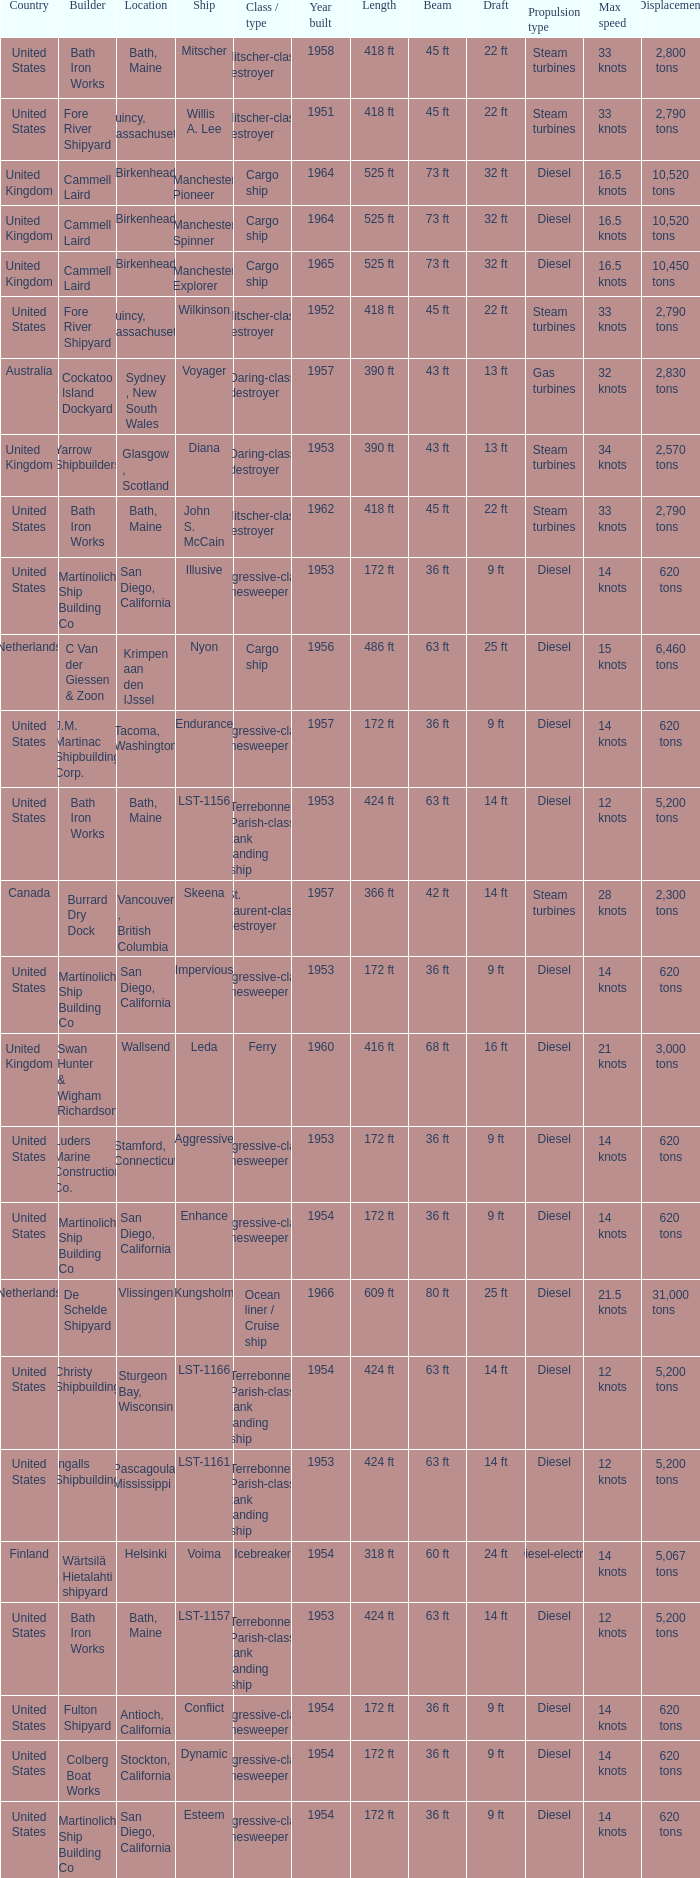Would you be able to parse every entry in this table? {'header': ['Country', 'Builder', 'Location', 'Ship', 'Class / type', 'Year built', 'Length', 'Beam', 'Draft', 'Propulsion type', 'Max speed', 'Displacement'], 'rows': [['United States', 'Bath Iron Works', 'Bath, Maine', 'Mitscher', 'Mitscher-class destroyer', '1958', '418 ft', '45 ft', '22 ft', 'Steam turbines', '33 knots', '2,800 tons'], ['United States', 'Fore River Shipyard', 'Quincy, Massachusetts', 'Willis A. Lee', 'Mitscher-class destroyer', '1951', '418 ft', '45 ft', '22 ft', 'Steam turbines', '33 knots', '2,790 tons'], ['United Kingdom', 'Cammell Laird', 'Birkenhead', 'Manchester Pioneer', 'Cargo ship', '1964', '525 ft', '73 ft', '32 ft', 'Diesel', '16.5 knots', '10,520 tons'], ['United Kingdom', 'Cammell Laird', 'Birkenhead', 'Manchester Spinner', 'Cargo ship', '1964', '525 ft', '73 ft', '32 ft', 'Diesel', '16.5 knots', '10,520 tons'], ['United Kingdom', 'Cammell Laird', 'Birkenhead', 'Manchester Explorer', 'Cargo ship', '1965', '525 ft', '73 ft', '32 ft', 'Diesel', '16.5 knots', '10,450 tons'], ['United States', 'Fore River Shipyard', 'Quincy, Massachusetts', 'Wilkinson', 'Mitscher-class destroyer', '1952', '418 ft', '45 ft', '22 ft', 'Steam turbines', '33 knots', '2,790 tons'], ['Australia', 'Cockatoo Island Dockyard', 'Sydney , New South Wales', 'Voyager', 'Daring-class destroyer', '1957', '390 ft', '43 ft', '13 ft', 'Gas turbines', '32 knots', '2,830 tons'], ['United Kingdom', 'Yarrow Shipbuilders', 'Glasgow , Scotland', 'Diana', 'Daring-class destroyer', '1953', '390 ft', '43 ft', '13 ft', 'Steam turbines', '34 knots', '2,570 tons'], ['United States', 'Bath Iron Works', 'Bath, Maine', 'John S. McCain', 'Mitscher-class destroyer', '1962', '418 ft', '45 ft', '22 ft', 'Steam turbines', '33 knots', '2,790 tons'], ['United States', 'Martinolich Ship Building Co', 'San Diego, California', 'Illusive', 'Aggressive-class minesweeper', '1953', '172 ft', '36 ft', '9 ft', 'Diesel', '14 knots', '620 tons'], ['Netherlands', 'C Van der Giessen & Zoon', 'Krimpen aan den IJssel', 'Nyon', 'Cargo ship', '1956', '486 ft', '63 ft', '25 ft', 'Diesel', '15 knots', '6,460 tons'], ['United States', 'J.M. Martinac Shipbuilding Corp.', 'Tacoma, Washington', 'Endurance', 'Aggressive-class minesweeper', '1957', '172 ft', '36 ft', '9 ft', 'Diesel', '14 knots', '620 tons'], ['United States', 'Bath Iron Works', 'Bath, Maine', 'LST-1156', 'Terrebonne Parish-class tank landing ship', '1953', '424 ft', '63 ft', '14 ft', 'Diesel', '12 knots', '5,200 tons'], ['Canada', 'Burrard Dry Dock', 'Vancouver , British Columbia', 'Skeena', 'St. Laurent-class destroyer', '1957', '366 ft', '42 ft', '14 ft', 'Steam turbines', '28 knots', '2,300 tons'], ['United States', 'Martinolich Ship Building Co', 'San Diego, California', 'Impervious', 'Aggressive-class minesweeper', '1953', '172 ft', '36 ft', '9 ft', 'Diesel', '14 knots', '620 tons'], ['United Kingdom', 'Swan Hunter & Wigham Richardson', 'Wallsend', 'Leda', 'Ferry', '1960', '416 ft', '68 ft', '16 ft', 'Diesel', '21 knots', '3,000 tons'], ['United States', 'Luders Marine Construction Co.', 'Stamford, Connecticut', 'Aggressive', 'Aggressive-class minesweeper', '1953', '172 ft', '36 ft', '9 ft', 'Diesel', '14 knots', '620 tons'], ['United States', 'Martinolich Ship Building Co', 'San Diego, California', 'Enhance', 'Aggressive-class minesweeper', '1954', '172 ft', '36 ft', '9 ft', 'Diesel', '14 knots', '620 tons'], ['Netherlands', 'De Schelde Shipyard', 'Vlissingen', 'Kungsholm', 'Ocean liner / Cruise ship', '1966', '609 ft', '80 ft', '25 ft', 'Diesel', '21.5 knots', '31,000 tons'], ['United States', 'Christy Shipbuilding', 'Sturgeon Bay, Wisconsin', 'LST-1166', 'Terrebonne Parish-class tank landing ship', '1954', '424 ft', '63 ft', '14 ft', 'Diesel', '12 knots', '5,200 tons'], ['United States', 'Ingalls Shipbuilding', 'Pascagoula, Mississippi', 'LST-1161', 'Terrebonne Parish-class tank landing ship', '1953', '424 ft', '63 ft', '14 ft', 'Diesel', '12 knots', '5,200 tons'], ['Finland', 'Wärtsilä Hietalahti shipyard', 'Helsinki', 'Voima', 'Icebreaker', '1954', '318 ft', '60 ft', '24 ft', 'Diesel-electric', '14 knots', '5,067 tons'], ['United States', 'Bath Iron Works', 'Bath, Maine', 'LST-1157', 'Terrebonne Parish-class tank landing ship', '1953', '424 ft', '63 ft', '14 ft', 'Diesel', '12 knots', '5,200 tons'], ['United States', 'Fulton Shipyard', 'Antioch, California', 'Conflict', 'Aggressive-class minesweeper', '1954', '172 ft', '36 ft', '9 ft', 'Diesel', '14 knots', '620 tons'], ['United States', 'Colberg Boat Works', 'Stockton, California', 'Dynamic', 'Aggressive-class minesweeper', '1954', '172 ft', '36 ft', '9 ft', 'Diesel', '14 knots', '620 tons'], ['United States', 'Martinolich Ship Building Co', 'San Diego, California', 'Esteem', 'Aggressive-class minesweeper', '1954', '172 ft', '36 ft', '9 ft', 'Diesel', '14 knots', '620 tons']]} What Ship was Built by Cammell Laird? Manchester Pioneer, Manchester Spinner, Manchester Explorer. 